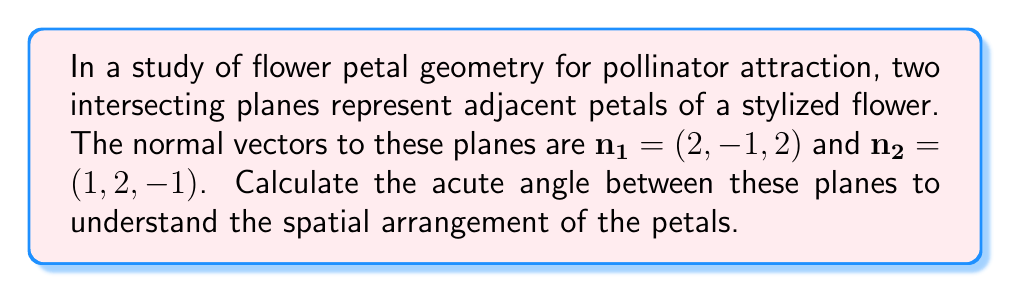Teach me how to tackle this problem. To find the angle between two intersecting planes, we can use the angle between their normal vectors. The process is as follows:

1) The formula for the angle $\theta$ between two vectors $\mathbf{a}$ and $\mathbf{b}$ is:

   $$\cos \theta = \frac{\mathbf{a} \cdot \mathbf{b}}{|\mathbf{a}||\mathbf{b}|}$$

2) Calculate the dot product $\mathbf{n_1} \cdot \mathbf{n_2}$:
   $$(2, -1, 2) \cdot (1, 2, -1) = 2(1) + (-1)(2) + 2(-1) = 2 - 2 - 2 = -2$$

3) Calculate the magnitudes of the vectors:
   $$|\mathbf{n_1}| = \sqrt{2^2 + (-1)^2 + 2^2} = \sqrt{9} = 3$$
   $$|\mathbf{n_2}| = \sqrt{1^2 + 2^2 + (-1)^2} = \sqrt{6}$$

4) Substitute into the formula:
   $$\cos \theta = \frac{-2}{3\sqrt{6}}$$

5) Take the inverse cosine (arccos) of both sides:
   $$\theta = \arccos\left(\frac{-2}{3\sqrt{6}}\right)$$

6) Calculate the result (approximately 1.9106 radians or 109.47°).

The acute angle is the complement of this angle: 180° - 109.47° = 70.53°.
Answer: 70.53° 